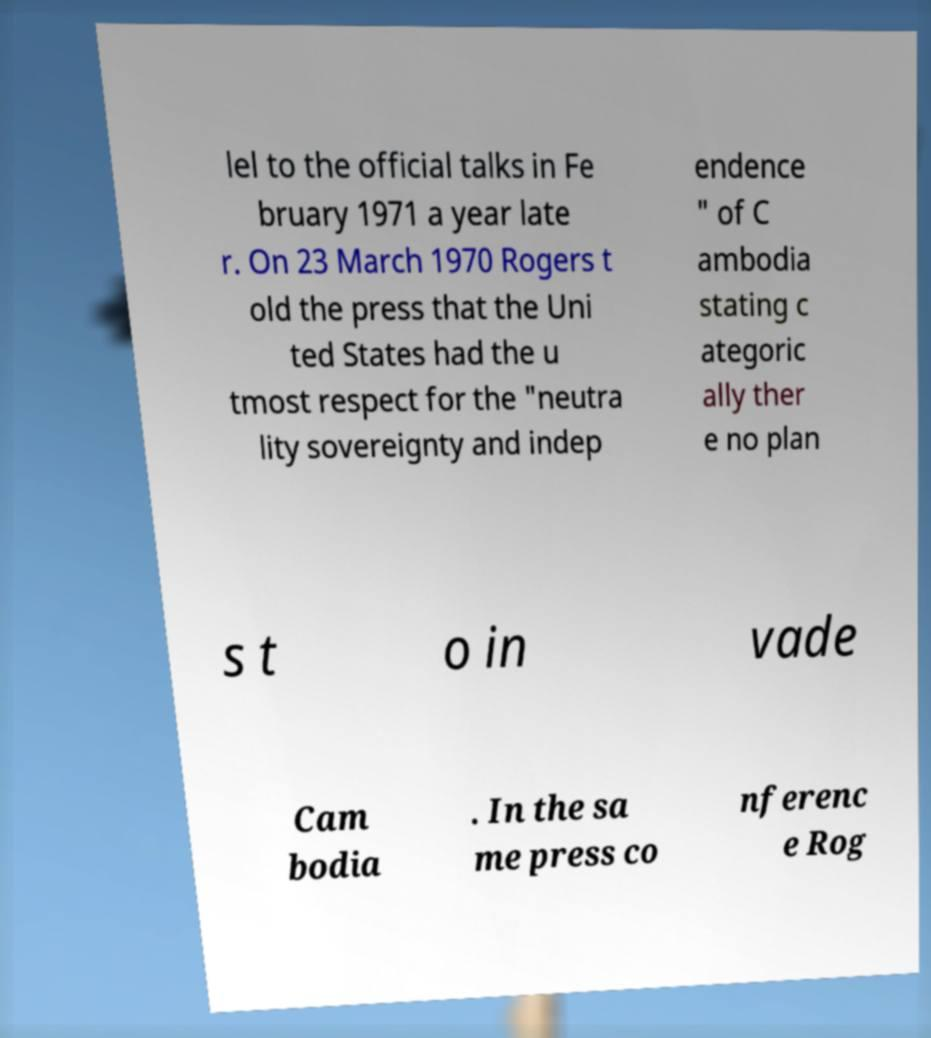For documentation purposes, I need the text within this image transcribed. Could you provide that? lel to the official talks in Fe bruary 1971 a year late r. On 23 March 1970 Rogers t old the press that the Uni ted States had the u tmost respect for the "neutra lity sovereignty and indep endence " of C ambodia stating c ategoric ally ther e no plan s t o in vade Cam bodia . In the sa me press co nferenc e Rog 